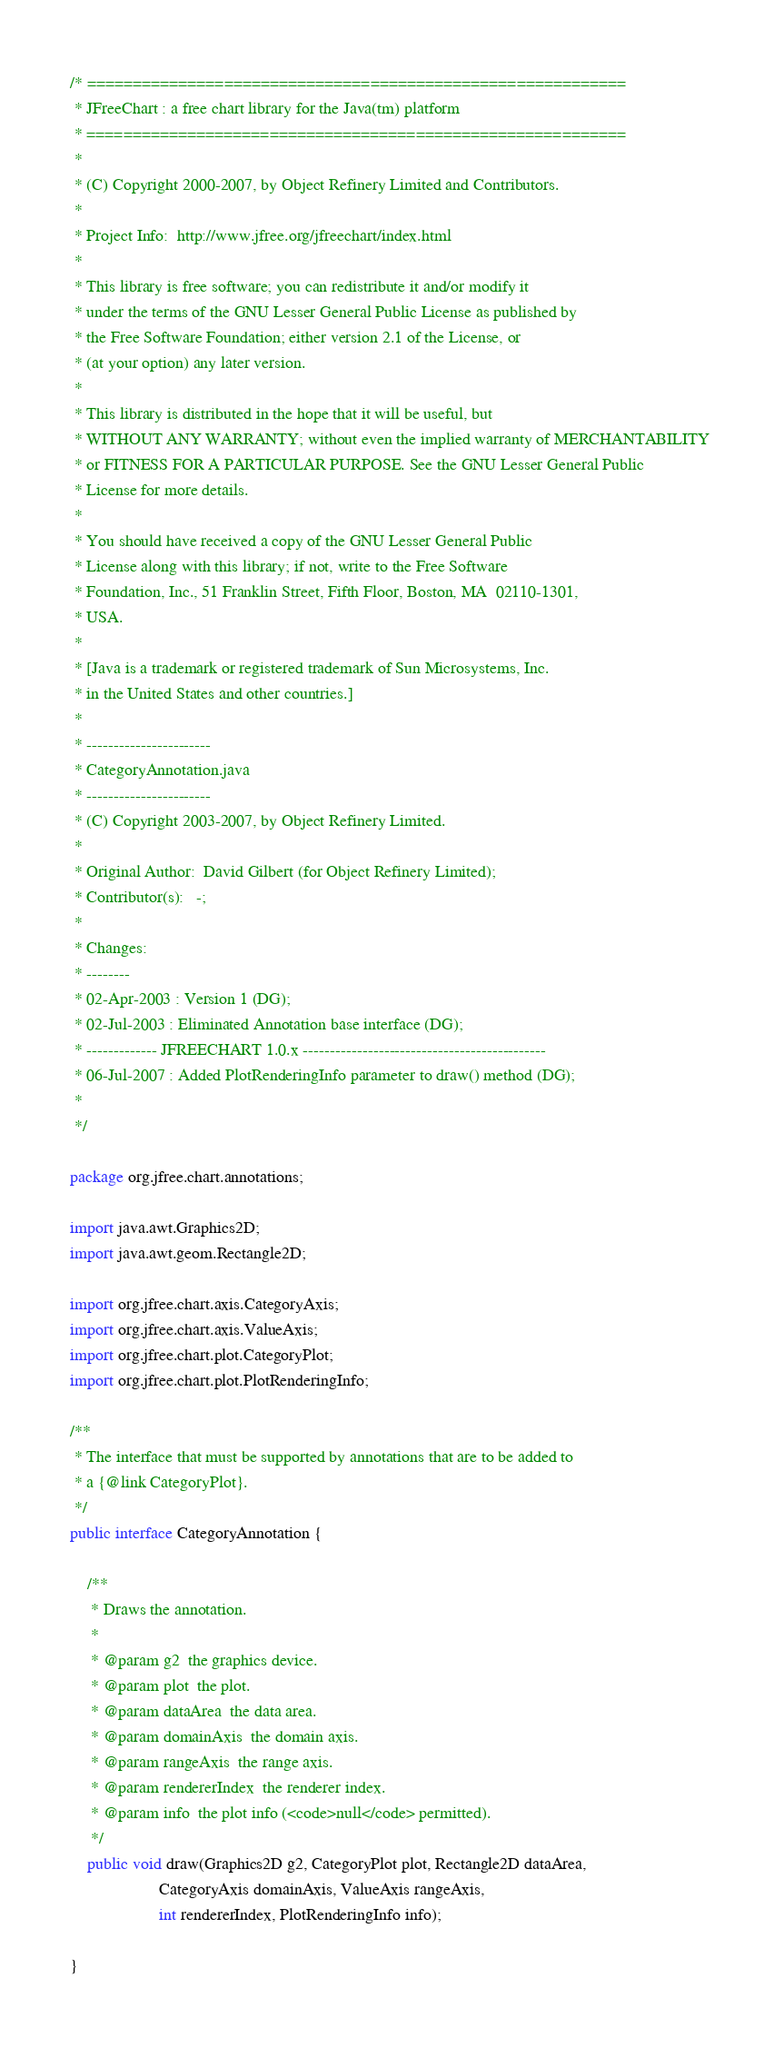<code> <loc_0><loc_0><loc_500><loc_500><_Java_>/* ===========================================================
 * JFreeChart : a free chart library for the Java(tm) platform
 * ===========================================================
 *
 * (C) Copyright 2000-2007, by Object Refinery Limited and Contributors.
 *
 * Project Info:  http://www.jfree.org/jfreechart/index.html
 *
 * This library is free software; you can redistribute it and/or modify it 
 * under the terms of the GNU Lesser General Public License as published by 
 * the Free Software Foundation; either version 2.1 of the License, or 
 * (at your option) any later version.
 *
 * This library is distributed in the hope that it will be useful, but 
 * WITHOUT ANY WARRANTY; without even the implied warranty of MERCHANTABILITY 
 * or FITNESS FOR A PARTICULAR PURPOSE. See the GNU Lesser General Public 
 * License for more details.
 *
 * You should have received a copy of the GNU Lesser General Public
 * License along with this library; if not, write to the Free Software
 * Foundation, Inc., 51 Franklin Street, Fifth Floor, Boston, MA  02110-1301, 
 * USA.  
 *
 * [Java is a trademark or registered trademark of Sun Microsystems, Inc. 
 * in the United States and other countries.]
 *
 * -----------------------
 * CategoryAnnotation.java
 * -----------------------
 * (C) Copyright 2003-2007, by Object Refinery Limited.
 *
 * Original Author:  David Gilbert (for Object Refinery Limited);
 * Contributor(s):   -;
 *
 * Changes:
 * --------
 * 02-Apr-2003 : Version 1 (DG);
 * 02-Jul-2003 : Eliminated Annotation base interface (DG);
 * ------------- JFREECHART 1.0.x ---------------------------------------------
 * 06-Jul-2007 : Added PlotRenderingInfo parameter to draw() method (DG);
 *
 */

package org.jfree.chart.annotations;

import java.awt.Graphics2D;
import java.awt.geom.Rectangle2D;

import org.jfree.chart.axis.CategoryAxis;
import org.jfree.chart.axis.ValueAxis;
import org.jfree.chart.plot.CategoryPlot;
import org.jfree.chart.plot.PlotRenderingInfo;

/**
 * The interface that must be supported by annotations that are to be added to 
 * a {@link CategoryPlot}.
 */
public interface CategoryAnnotation {

    /**
     * Draws the annotation.
     *
     * @param g2  the graphics device.
     * @param plot  the plot.
     * @param dataArea  the data area.
     * @param domainAxis  the domain axis.
     * @param rangeAxis  the range axis.
     * @param rendererIndex  the renderer index.
     * @param info  the plot info (<code>null</code> permitted).
     */
    public void draw(Graphics2D g2, CategoryPlot plot, Rectangle2D dataArea,
                     CategoryAxis domainAxis, ValueAxis rangeAxis, 
                     int rendererIndex, PlotRenderingInfo info);

}
</code> 